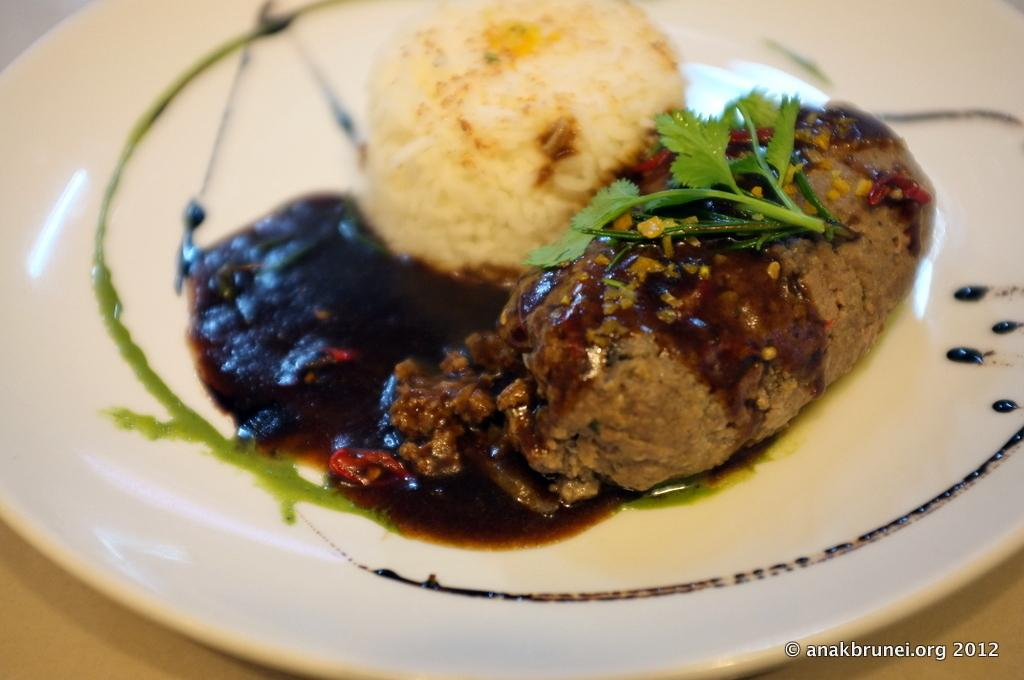What types of items can be seen in the image? There are food items in the image. What is the color of the plate on which the food items are placed? The plate is white in color. What type of muscle can be seen flexing in the image? There is no muscle visible in the image; it features food items on a white plate. 